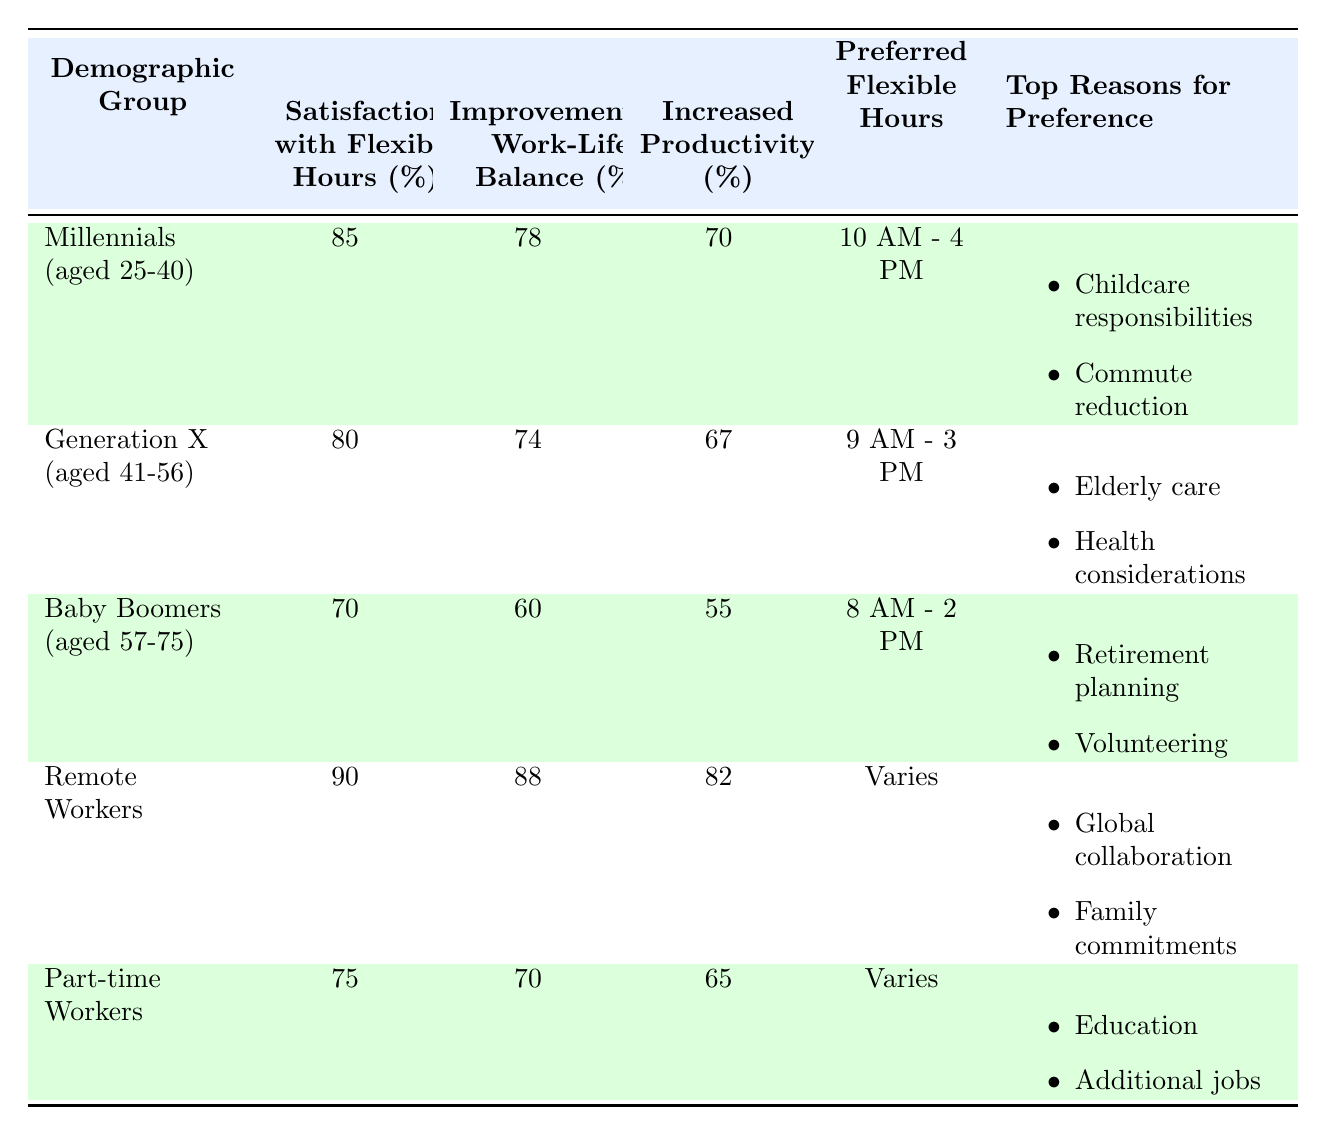What's the satisfaction percentage with flexible hours for Millennials? The table indicates that Millennials (aged 25-40) have a satisfaction percentage of 85% with flexible working hours.
Answer: 85% What are the top reasons for Baby Boomers preferring flexible working hours? The top reasons provided for Baby Boomers (aged 57-75) include "Retirement planning" and "Volunteering."
Answer: Retirement planning, Volunteering Which demographic group has the highest perceived improvement in work-life balance? By comparing the percentages, Remote Workers show the highest improvement in work-life balance at 88%, while other groups have lower percentages.
Answer: Remote Workers What is the difference in satisfaction percentage with flexible hours between Generation X and Part-time Workers? Generation X has a satisfaction percentage of 80% while Part-time Workers have 75%. The difference is 80% - 75% = 5%.
Answer: 5% Are Millennials more satisfied with flexible hours than Baby Boomers? Yes, Millennials have a higher satisfaction percentage (85%) compared to Baby Boomers (70%), indicating greater satisfaction.
Answer: Yes What is the average improvement in work-life balance across all groups? The improvement percentages are: Millennials 78%, Generation X 74%, Baby Boomers 60%, Remote Workers 88%, and Part-time Workers 70%. The sum is 78 + 74 + 60 + 88 + 70 = 370, and there are 5 groups, so the average is 370 / 5 = 74%.
Answer: 74% Which demographic group is associated with the preferred flexible hours of 10 AM - 4 PM? The table specifies that Millennials (aged 25-40) prefer flexible hours of 10 AM - 4 PM.
Answer: Millennials Is it true that Baby Boomers showed an increase in productivity of more than 50%? Yes, the table indicates that Baby Boomers have increased their productivity by 55%, which is indeed more than 50%.
Answer: Yes What group demonstrates the least increase in productivity, and what is their percentage? Baby Boomers show the least increase in productivity at 55%, which is lower than all other groups indicated in the table.
Answer: Baby Boomers, 55% 